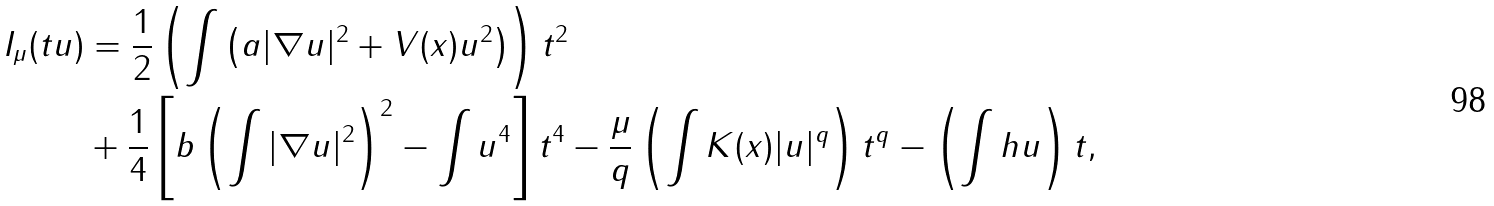<formula> <loc_0><loc_0><loc_500><loc_500>I _ { \mu } ( t u ) & = \frac { 1 } { 2 } \left ( \int \left ( a | \nabla u | ^ { 2 } + V ( x ) u ^ { 2 } \right ) \right ) t ^ { 2 } \\ & + \frac { 1 } { 4 } \left [ b \left ( \int | \nabla u | ^ { 2 } \right ) ^ { 2 } - \int u ^ { 4 } \right ] t ^ { 4 } - \frac { \mu } { q } \left ( \int K ( x ) | u | ^ { q } \right ) t ^ { q } - \left ( \int h u \right ) t ,</formula> 